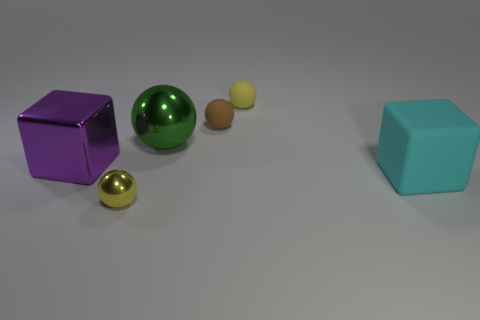Are there the same number of large objects left of the brown rubber ball and small rubber things?
Provide a short and direct response. Yes. What number of spheres are either large cyan things or purple metallic things?
Keep it short and to the point. 0. Do the tiny metal sphere and the large shiny cube have the same color?
Your answer should be compact. No. Are there the same number of green things right of the large cyan block and rubber things behind the brown matte sphere?
Your answer should be compact. No. The large sphere has what color?
Provide a succinct answer. Green. How many things are yellow balls that are on the left side of the green sphere or balls?
Your answer should be compact. 4. There is a yellow sphere behind the yellow metallic thing; is it the same size as the metallic ball that is in front of the big purple metal cube?
Give a very brief answer. Yes. How many objects are small yellow objects that are in front of the small brown rubber sphere or yellow balls that are to the left of the big green ball?
Make the answer very short. 1. Are the cyan block and the yellow object that is in front of the small brown rubber object made of the same material?
Your answer should be very brief. No. There is a large thing that is to the right of the big purple shiny object and left of the rubber block; what is its shape?
Your answer should be very brief. Sphere. 